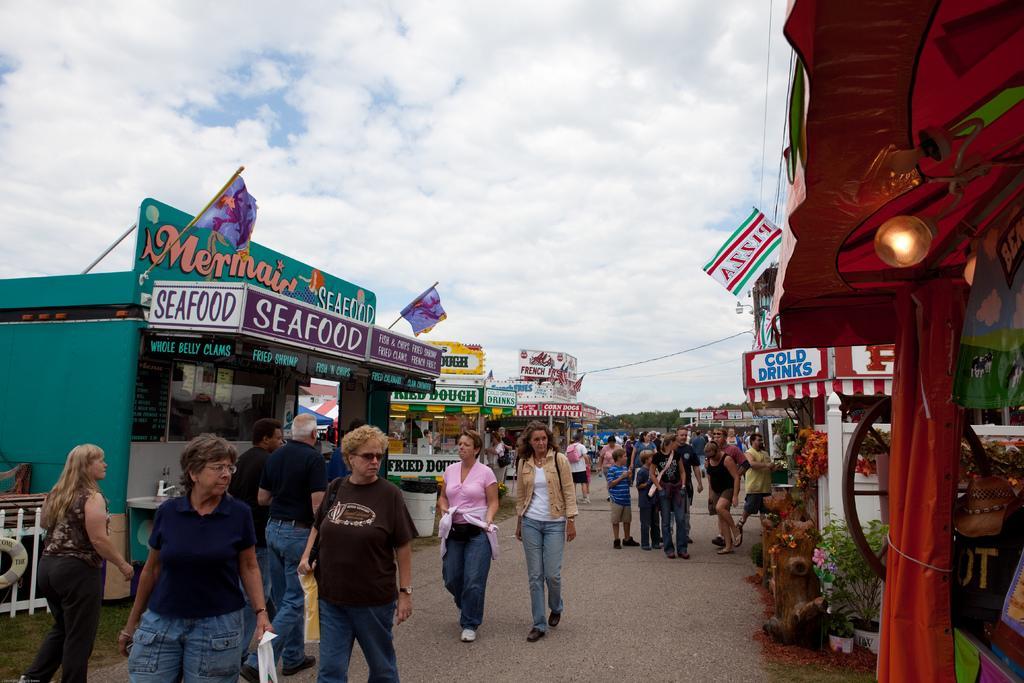Please provide a concise description of this image. As we can see in the image there are buildings, banner, light, plants and few people here and there. On the top there is sky and clouds. 